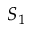<formula> <loc_0><loc_0><loc_500><loc_500>S _ { 1 }</formula> 